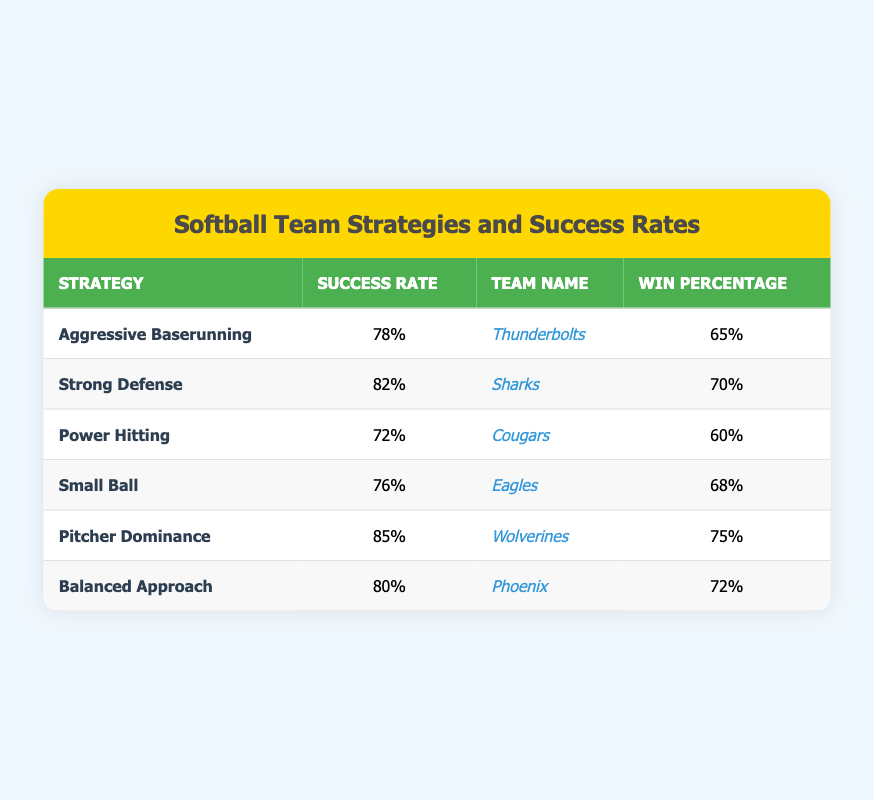What is the success rate of the Sharks' strategy? The success rate for the Sharks is directly listed in the table under the "Success Rate" column for their strategy, which is "Strong Defense". The value there is 82%.
Answer: 82% Which team has the highest win percentage? To determine this, we compare the win percentages listed in the "Win Percentage" column. The highest value in the column is 75%, which belongs to the Wolverines.
Answer: Wolverines Is the success rate for the Cougars higher than the win percentage for the Eagles? We look for the success rate of the Cougars, which is 72%, and the win percentage of the Eagles, which is 68%. Since 72% is greater than 68%, the statement is true.
Answer: Yes What is the average success rate of all strategies? First, we sum the success rates: 78 + 82 + 72 + 76 + 85 + 80 = 473. There are 6 strategies, so the average is 473 divided by 6, which is approximately 78.83.
Answer: 78.83 Which strategy has a success rate above 80%? We can filter through the "Success Rate" column and check for values above 80%. The strategies that meet this criterion are "Strong Defense" (82%) and "Pitcher Dominance" (85%).
Answer: Strong Defense, Pitcher Dominance If we consider winning percentages, which two teams have win percentages that are more than 70%? By examining the "Win Percentage" column, we see that the teams with values greater than 70% are the Sharks (70%), Wolverines (75%), and Phoenix (72%). Thus, the teams are Sharks and Wolverines.
Answer: Sharks, Wolverines Does the team strategy "Power Hitting" have a success rate lower than the average success rate? As calculated previously, the average success rate is 78.83%. The success rate for the Cougars using "Power Hitting" is 72%, which is indeed lower than 78.83%.
Answer: Yes What is the win percentage difference between the team with the highest and lowest success rates? The highest success rate is from the Wolverines (85%) and the lowest is from the Cougars (72%). Their respective win percentages are 75% and 60%. The difference is 75% - 60% = 15%.
Answer: 15% 